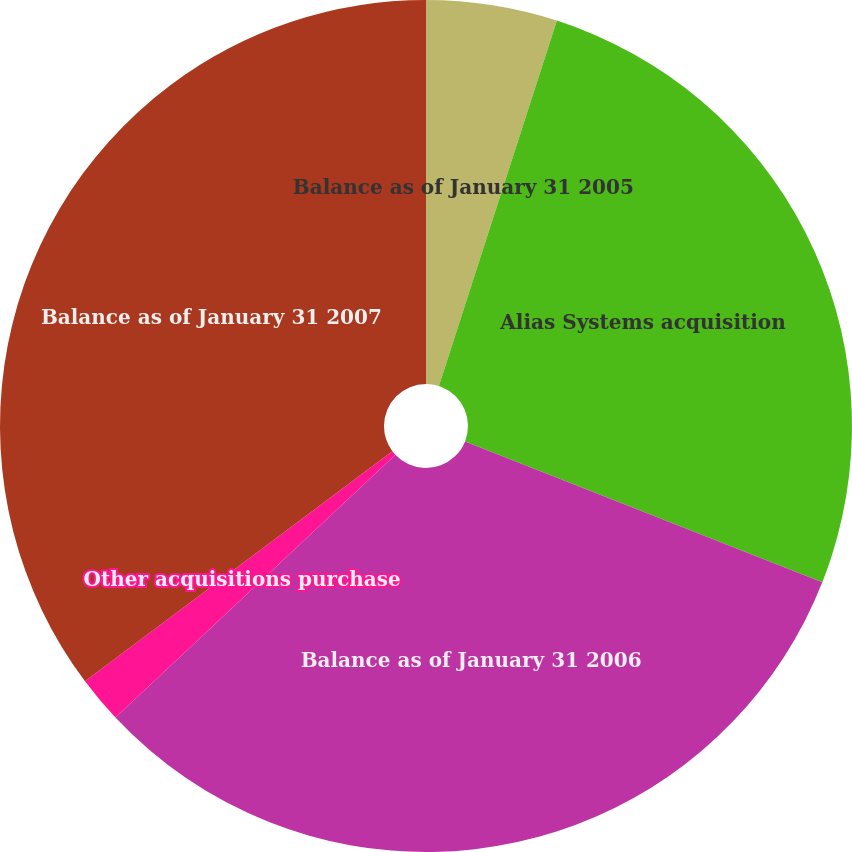Convert chart to OTSL. <chart><loc_0><loc_0><loc_500><loc_500><pie_chart><fcel>Balance as of January 31 2005<fcel>Alias Systems acquisition<fcel>Balance as of January 31 2006<fcel>Other acquisitions purchase<fcel>Balance as of January 31 2007<nl><fcel>4.97%<fcel>26.01%<fcel>32.02%<fcel>1.77%<fcel>35.23%<nl></chart> 